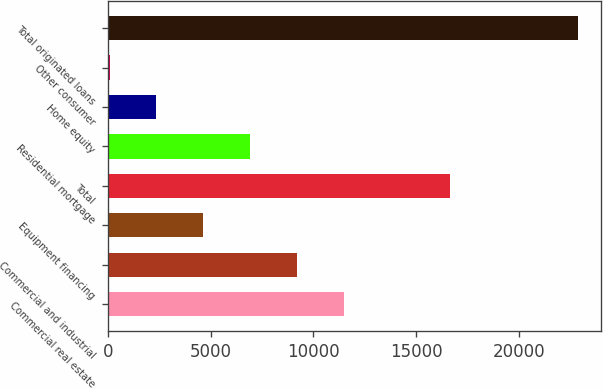Convert chart to OTSL. <chart><loc_0><loc_0><loc_500><loc_500><bar_chart><fcel>Commercial real estate<fcel>Commercial and industrial<fcel>Equipment financing<fcel>Total<fcel>Residential mortgage<fcel>Home equity<fcel>Other consumer<fcel>Total originated loans<nl><fcel>11467.9<fcel>9188.38<fcel>4629.44<fcel>16629.1<fcel>6908.91<fcel>2349.97<fcel>70.5<fcel>22865.2<nl></chart> 